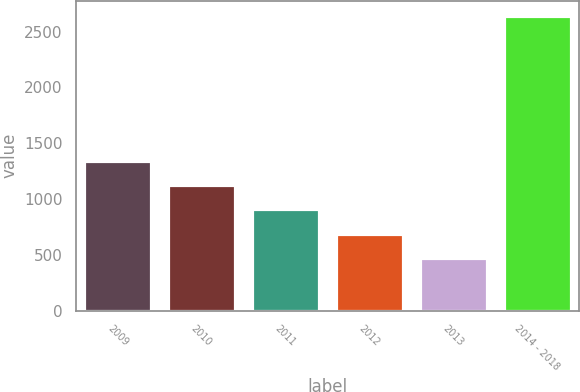Convert chart. <chart><loc_0><loc_0><loc_500><loc_500><bar_chart><fcel>2009<fcel>2010<fcel>2011<fcel>2012<fcel>2013<fcel>2014 - 2018<nl><fcel>1340.8<fcel>1123.6<fcel>906.4<fcel>689.2<fcel>472<fcel>2644<nl></chart> 